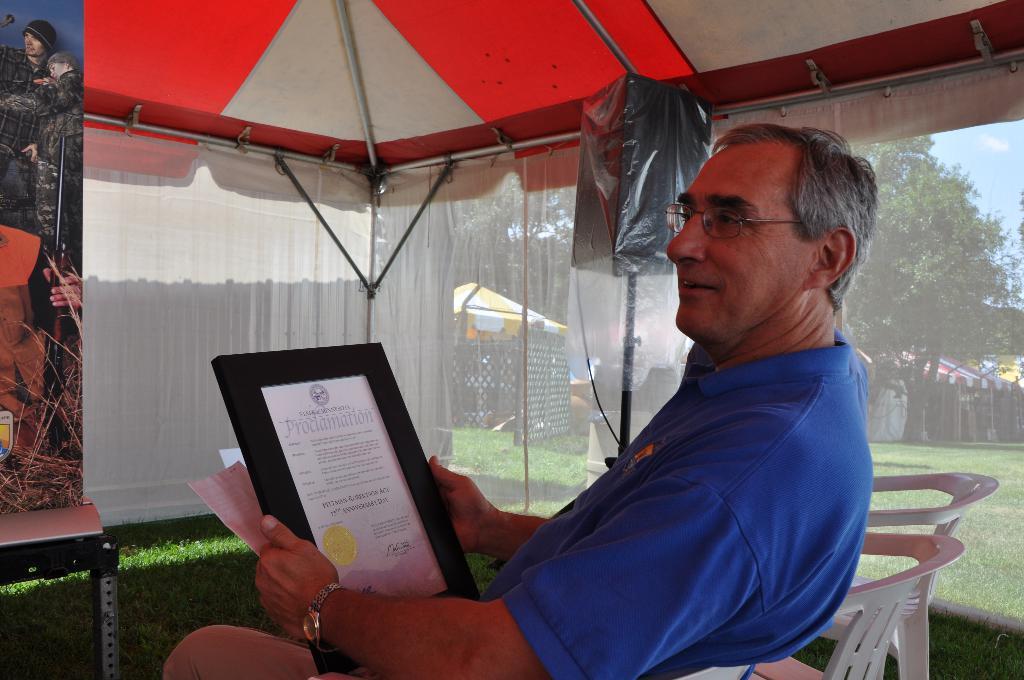Describe this image in one or two sentences. As we can see in the image there are chairs, grass, trees, tents, curtains, banner, table, a man wearing blue color t shirt and holding a photo frame. 